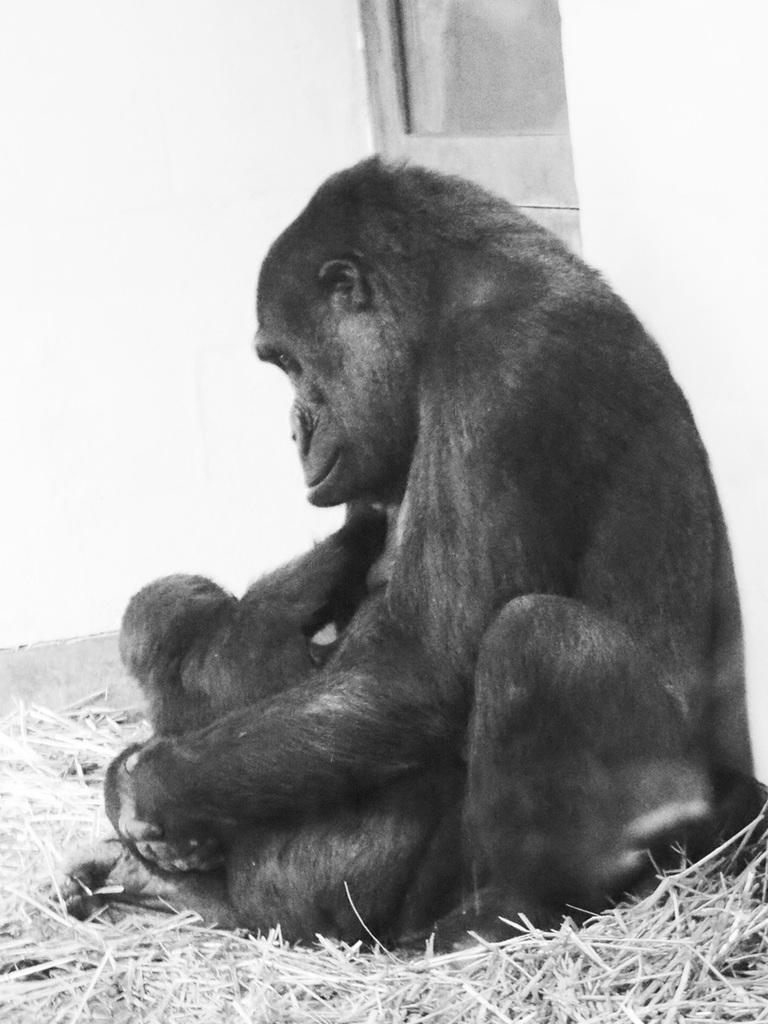In one or two sentences, can you explain what this image depicts? Here we can see gorilla, infant gorilla, dried grass and wall. 